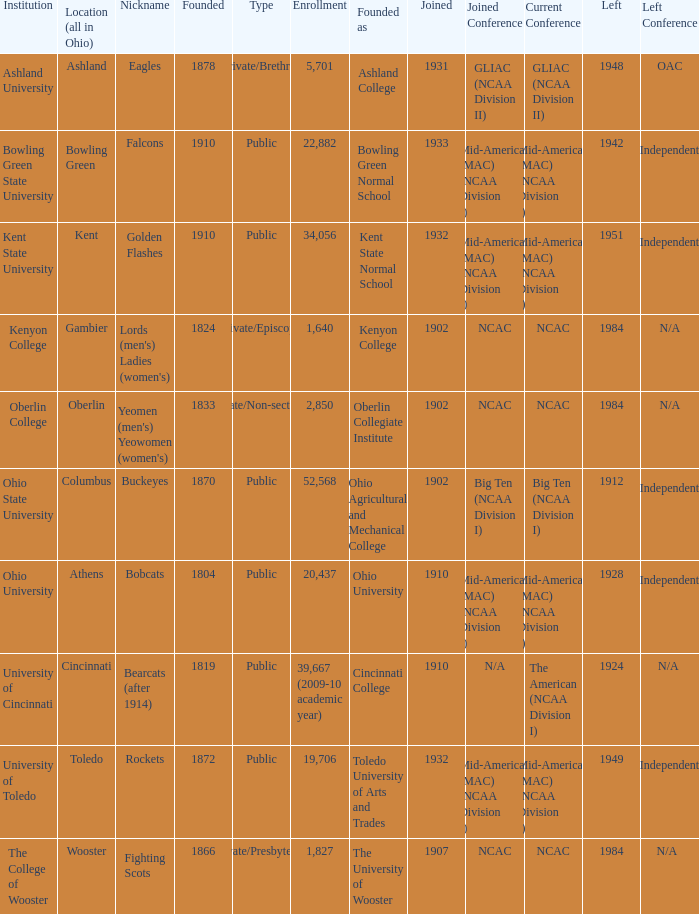What is the enrollment for Ashland University? 5701.0. 